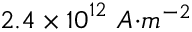Convert formula to latex. <formula><loc_0><loc_0><loc_500><loc_500>2 . 4 \times { 1 0 } ^ { 1 2 } { \ A { m } ^ { - 2 }</formula> 